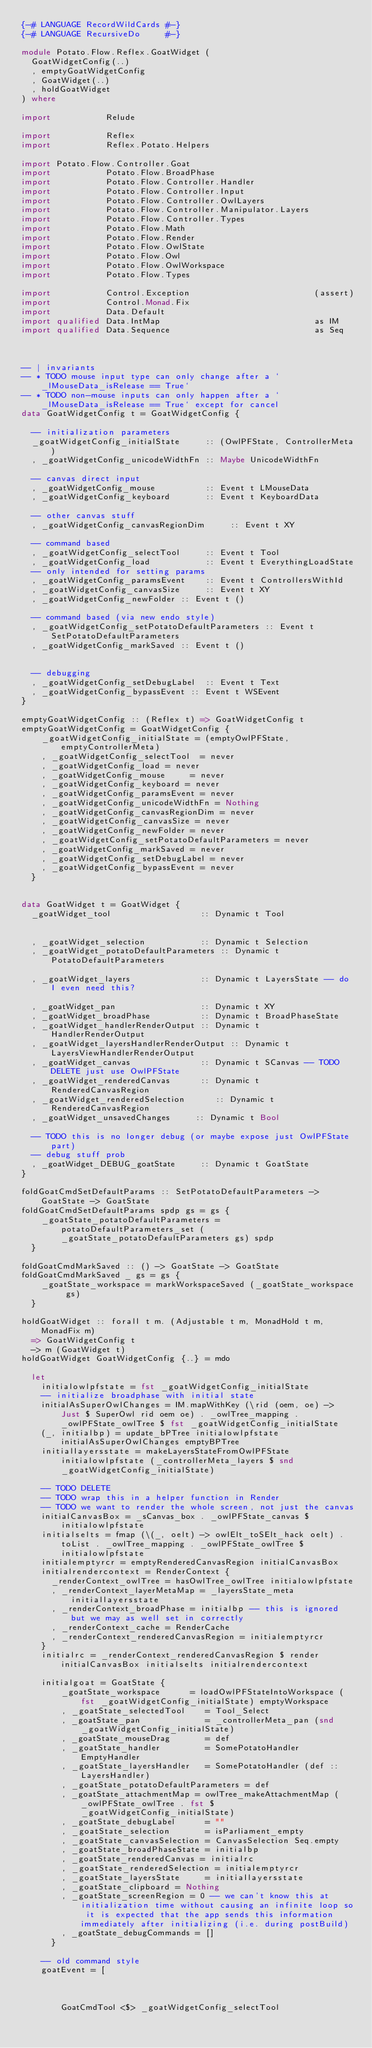<code> <loc_0><loc_0><loc_500><loc_500><_Haskell_>{-# LANGUAGE RecordWildCards #-}
{-# LANGUAGE RecursiveDo     #-}

module Potato.Flow.Reflex.GoatWidget (
  GoatWidgetConfig(..)
  , emptyGoatWidgetConfig
  , GoatWidget(..)
  , holdGoatWidget
) where

import           Relude

import           Reflex
import           Reflex.Potato.Helpers

import Potato.Flow.Controller.Goat
import           Potato.Flow.BroadPhase
import           Potato.Flow.Controller.Handler
import           Potato.Flow.Controller.Input
import           Potato.Flow.Controller.OwlLayers
import           Potato.Flow.Controller.Manipulator.Layers
import           Potato.Flow.Controller.Types
import           Potato.Flow.Math
import           Potato.Flow.Render
import           Potato.Flow.OwlState
import           Potato.Flow.Owl
import           Potato.Flow.OwlWorkspace
import           Potato.Flow.Types

import           Control.Exception                         (assert)
import           Control.Monad.Fix
import           Data.Default
import qualified Data.IntMap                               as IM
import qualified Data.Sequence                             as Seq



-- | invariants
-- * TODO mouse input type can only change after a `_lMouseData_isRelease == True`
-- * TODO non-mouse inputs can only happen after a `_lMouseData_isRelease == True` except for cancel
data GoatWidgetConfig t = GoatWidgetConfig {

  -- initialization parameters
  _goatWidgetConfig_initialState     :: (OwlPFState, ControllerMeta)
  , _goatWidgetConfig_unicodeWidthFn :: Maybe UnicodeWidthFn

  -- canvas direct input
  , _goatWidgetConfig_mouse          :: Event t LMouseData
  , _goatWidgetConfig_keyboard       :: Event t KeyboardData

  -- other canvas stuff
  , _goatWidgetConfig_canvasRegionDim     :: Event t XY

  -- command based
  , _goatWidgetConfig_selectTool     :: Event t Tool
  , _goatWidgetConfig_load           :: Event t EverythingLoadState
  -- only intended for setting params
  , _goatWidgetConfig_paramsEvent    :: Event t ControllersWithId
  , _goatWidgetConfig_canvasSize     :: Event t XY
  , _goatWidgetConfig_newFolder :: Event t ()

  -- command based (via new endo style)
  , _goatWidgetConfig_setPotatoDefaultParameters :: Event t SetPotatoDefaultParameters
  , _goatWidgetConfig_markSaved :: Event t ()


  -- debugging
  , _goatWidgetConfig_setDebugLabel  :: Event t Text
  , _goatWidgetConfig_bypassEvent :: Event t WSEvent
}

emptyGoatWidgetConfig :: (Reflex t) => GoatWidgetConfig t
emptyGoatWidgetConfig = GoatWidgetConfig {
    _goatWidgetConfig_initialState = (emptyOwlPFState, emptyControllerMeta)
    , _goatWidgetConfig_selectTool  = never
    , _goatWidgetConfig_load = never
    , _goatWidgetConfig_mouse     = never
    , _goatWidgetConfig_keyboard = never
    , _goatWidgetConfig_paramsEvent = never
    , _goatWidgetConfig_unicodeWidthFn = Nothing
    , _goatWidgetConfig_canvasRegionDim = never
    , _goatWidgetConfig_canvasSize = never
    , _goatWidgetConfig_newFolder = never
    , _goatWidgetConfig_setPotatoDefaultParameters = never
    , _goatWidgetConfig_markSaved = never
    , _goatWidgetConfig_setDebugLabel = never
    , _goatWidgetConfig_bypassEvent = never
  }


data GoatWidget t = GoatWidget {
  _goatWidget_tool                  :: Dynamic t Tool


  , _goatWidget_selection           :: Dynamic t Selection
  , _goatWidget_potatoDefaultParameters :: Dynamic t PotatoDefaultParameters

  , _goatWidget_layers              :: Dynamic t LayersState -- do I even need this?

  , _goatWidget_pan                 :: Dynamic t XY
  , _goatWidget_broadPhase          :: Dynamic t BroadPhaseState
  , _goatWidget_handlerRenderOutput :: Dynamic t HandlerRenderOutput
  , _goatWidget_layersHandlerRenderOutput :: Dynamic t LayersViewHandlerRenderOutput
  , _goatWidget_canvas              :: Dynamic t SCanvas -- TODO DELETE just use OwlPFState
  , _goatWidget_renderedCanvas      :: Dynamic t RenderedCanvasRegion
  , _goatWidget_renderedSelection      :: Dynamic t RenderedCanvasRegion
  , _goatWidget_unsavedChanges     :: Dynamic t Bool

  -- TODO this is no longer debug (or maybe expose just OwlPFState part)
  -- debug stuff prob
  , _goatWidget_DEBUG_goatState     :: Dynamic t GoatState
}

foldGoatCmdSetDefaultParams :: SetPotatoDefaultParameters -> GoatState -> GoatState
foldGoatCmdSetDefaultParams spdp gs = gs {
    _goatState_potatoDefaultParameters = potatoDefaultParameters_set (_goatState_potatoDefaultParameters gs) spdp
  }

foldGoatCmdMarkSaved :: () -> GoatState -> GoatState
foldGoatCmdMarkSaved _ gs = gs {
    _goatState_workspace = markWorkspaceSaved (_goatState_workspace gs)
  }

holdGoatWidget :: forall t m. (Adjustable t m, MonadHold t m, MonadFix m)
  => GoatWidgetConfig t
  -> m (GoatWidget t)
holdGoatWidget GoatWidgetConfig {..} = mdo

  let
    initialowlpfstate = fst _goatWidgetConfig_initialState
    -- initialize broadphase with initial state
    initialAsSuperOwlChanges = IM.mapWithKey (\rid (oem, oe) -> Just $ SuperOwl rid oem oe) . _owlTree_mapping . _owlPFState_owlTree $ fst _goatWidgetConfig_initialState
    (_, initialbp) = update_bPTree initialowlpfstate initialAsSuperOwlChanges emptyBPTree
    initiallayersstate = makeLayersStateFromOwlPFState initialowlpfstate (_controllerMeta_layers $ snd _goatWidgetConfig_initialState)

    -- TODO DELETE
    -- TODO wrap this in a helper function in Render
    -- TODO we want to render the whole screen, not just the canvas
    initialCanvasBox = _sCanvas_box . _owlPFState_canvas $ initialowlpfstate
    initialselts = fmap (\(_, oelt) -> owlElt_toSElt_hack oelt) . toList . _owlTree_mapping . _owlPFState_owlTree $ initialowlpfstate
    initialemptyrcr = emptyRenderedCanvasRegion initialCanvasBox
    initialrendercontext = RenderContext {
      _renderContext_owlTree = hasOwlTree_owlTree initialowlpfstate
      , _renderContext_layerMetaMap = _layersState_meta initiallayersstate
      , _renderContext_broadPhase = initialbp -- this is ignored but we may as well set in correctly
      , _renderContext_cache = RenderCache
      , _renderContext_renderedCanvasRegion = initialemptyrcr
    }
    initialrc = _renderContext_renderedCanvasRegion $ render initialCanvasBox initialselts initialrendercontext

    initialgoat = GoatState {
        _goatState_workspace      = loadOwlPFStateIntoWorkspace (fst _goatWidgetConfig_initialState) emptyWorkspace
        , _goatState_selectedTool    = Tool_Select
        , _goatState_pan             = _controllerMeta_pan (snd _goatWidgetConfig_initialState)
        , _goatState_mouseDrag       = def
        , _goatState_handler         = SomePotatoHandler EmptyHandler
        , _goatState_layersHandler   = SomePotatoHandler (def :: LayersHandler)
        , _goatState_potatoDefaultParameters = def
        , _goatState_attachmentMap = owlTree_makeAttachmentMap (_owlPFState_owlTree . fst $ _goatWidgetConfig_initialState)
        , _goatState_debugLabel      = ""
        , _goatState_selection       = isParliament_empty
        , _goatState_canvasSelection = CanvasSelection Seq.empty
        , _goatState_broadPhaseState = initialbp
        , _goatState_renderedCanvas = initialrc
        , _goatState_renderedSelection = initialemptyrcr
        , _goatState_layersState     = initiallayersstate
        , _goatState_clipboard = Nothing
        , _goatState_screenRegion = 0 -- we can't know this at initialization time without causing an infinite loop so it is expected that the app sends this information immediately after initializing (i.e. during postBuild)
        , _goatState_debugCommands = []
      }

    -- old command style
    goatEvent = [



        GoatCmdTool <$> _goatWidgetConfig_selectTool</code> 